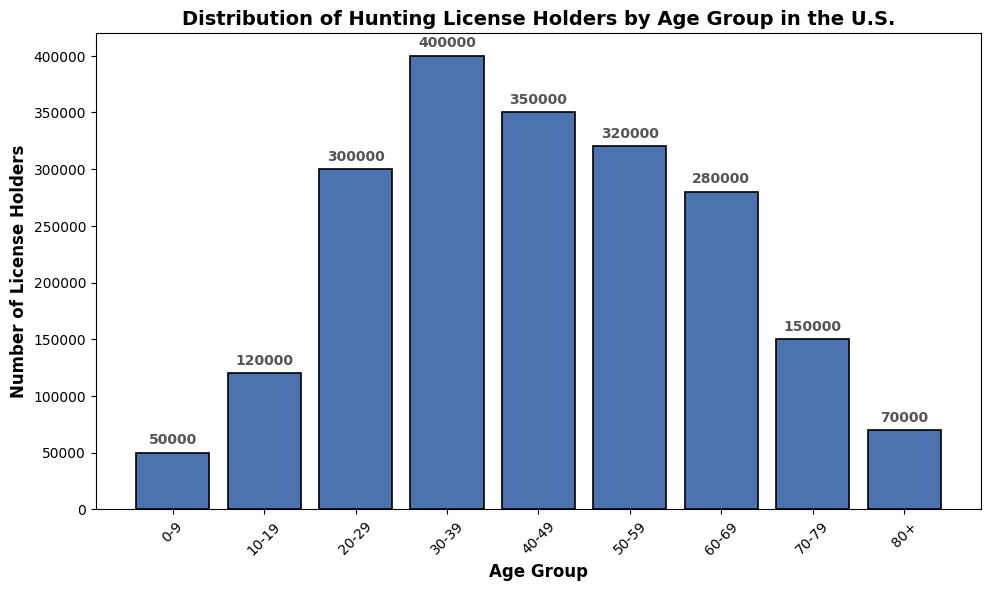Which age group has the highest number of hunting license holders? By observing the height of the bars, the 30-39 age group has the tallest bar, indicating the highest number of hunting license holders.
Answer: 30-39 Which age group has the fewest hunting license holders? By observing the height of the bars, the 0-9 age group has the shortest bar, indicating the fewest number of hunting license holders.
Answer: 0-9 How many more license holders are in the 30-39 age group compared to the 60-69 age group? The number of license holders in the 30-39 age group is 400000 while in the 60-69 age group it is 280000. The difference is 400000 - 280000 = 120000.
Answer: 120000 What is the combined total of license holders for the 50-59 and 60-69 age groups? The number of license holders in the 50-59 age group is 320000 and in the 60-69 age group it is 280000. The combined total is 320000 + 280000 = 600000.
Answer: 600000 Which age group has approximately half the number of license holders as the 30-39 age group? The number of license holders in the 30-39 age group is 400000. Approximately half of 400000 is 200000. By observing the bars, the 10-19 age group has 120000 license holders, which is closest to half of 400000.
Answer: 10-19 What is the difference in the number of license holders between the 40-49 age group and the 70-79 age group? The number of license holders in the 40-49 age group is 350000 while in the 70-79 age group it is 150000. The difference is 350000 - 150000 = 200000.
Answer: 200000 What is the average number of license holders across all age groups? The total number of license holders is the sum of all age groups: 50000 + 120000 + 300000 + 400000 + 350000 + 320000 + 280000 + 150000 + 70000 = 2040000. There are 9 age groups, so the average is 2040000 / 9 ≈ 226667.
Answer: 226667 